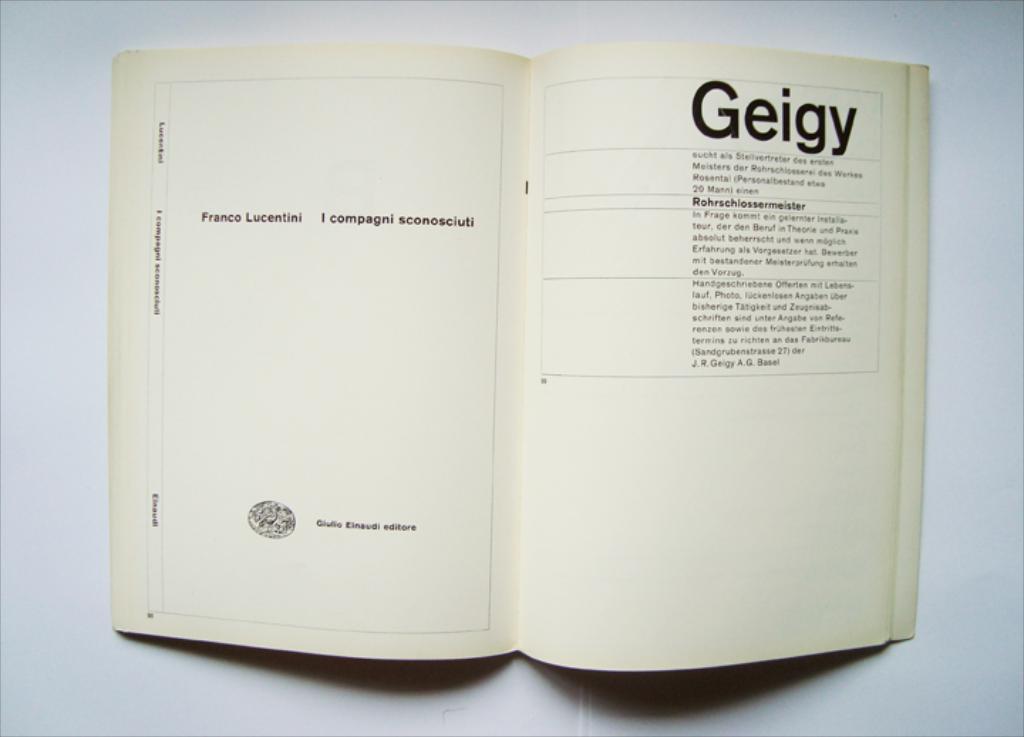What is the largest word in the image in terms of visibility?
Make the answer very short. Geigy. 